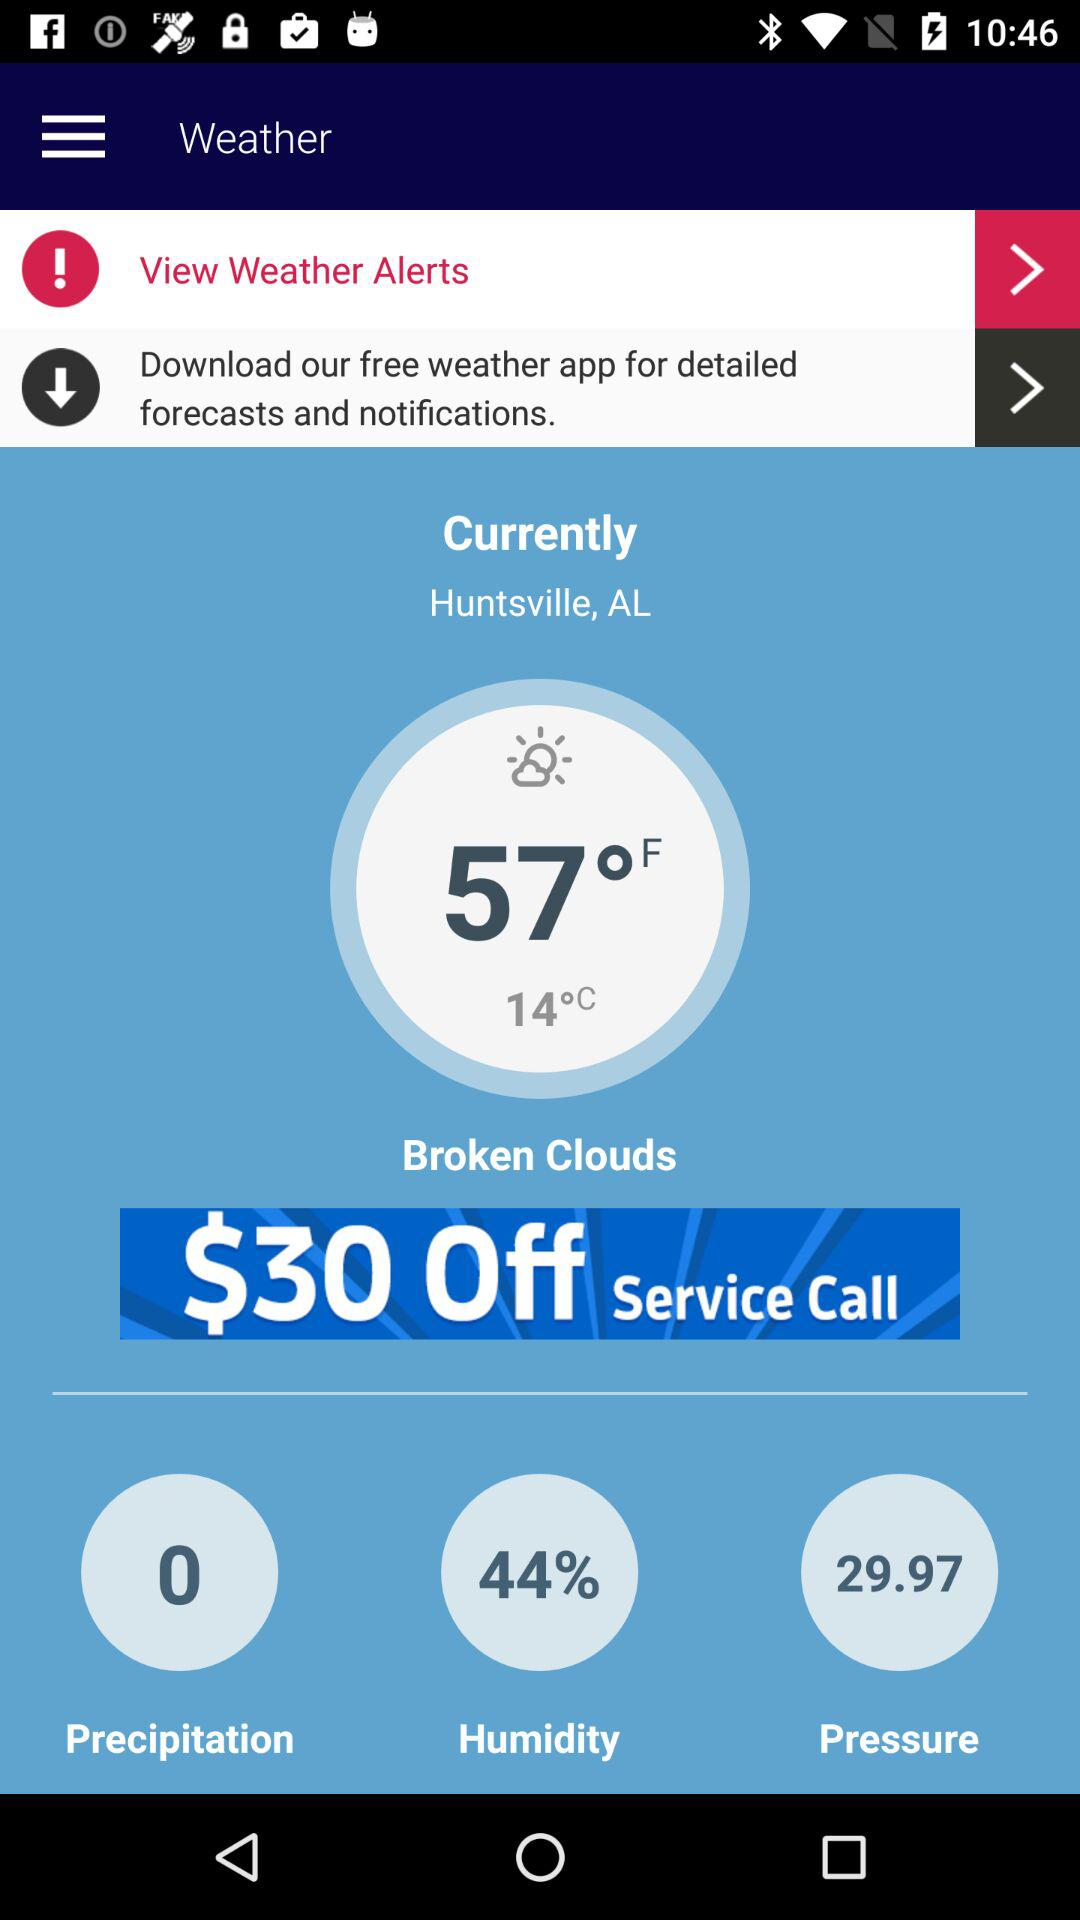What is the current location? The current location is Huntsville, AL. 